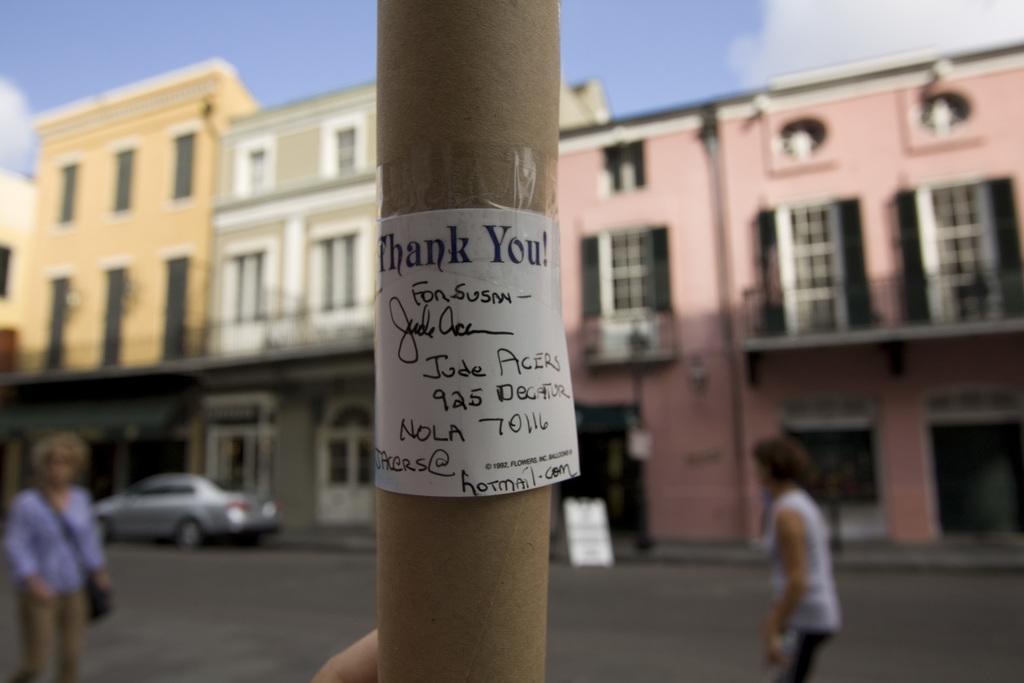Can you describe this image briefly? I can see a paper, which is attached to a cardboard tube roll. There are two people standing. These are the buildings with the windows and doors. Here is a car, which is parked. This is the sky. 